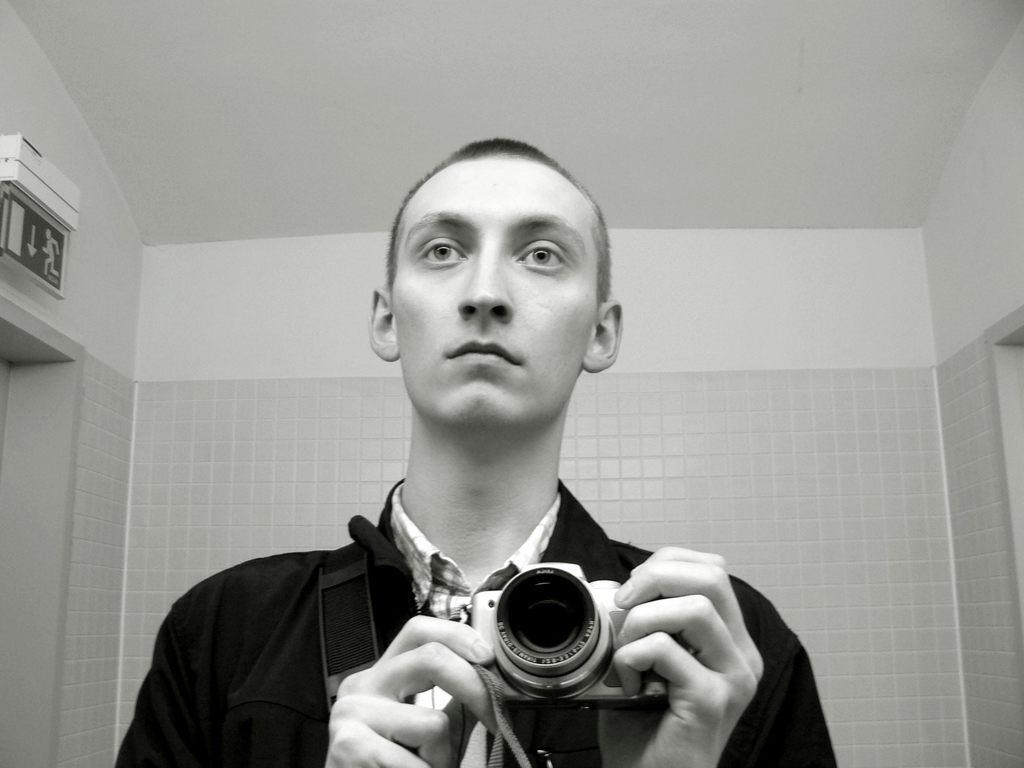Who is present in the image? There is a man in the image. What is the man holding in the image? The man is holding a camera. Where was the image taken? The image was taken in a room. What can be seen in the background of the image? There is a wall in the background of the image. What is the man wearing in the image? The man is wearing a black jacket. What type of advice is the man giving on the bridge in the image? There is no bridge present in the image, and the man is not giving any advice. 